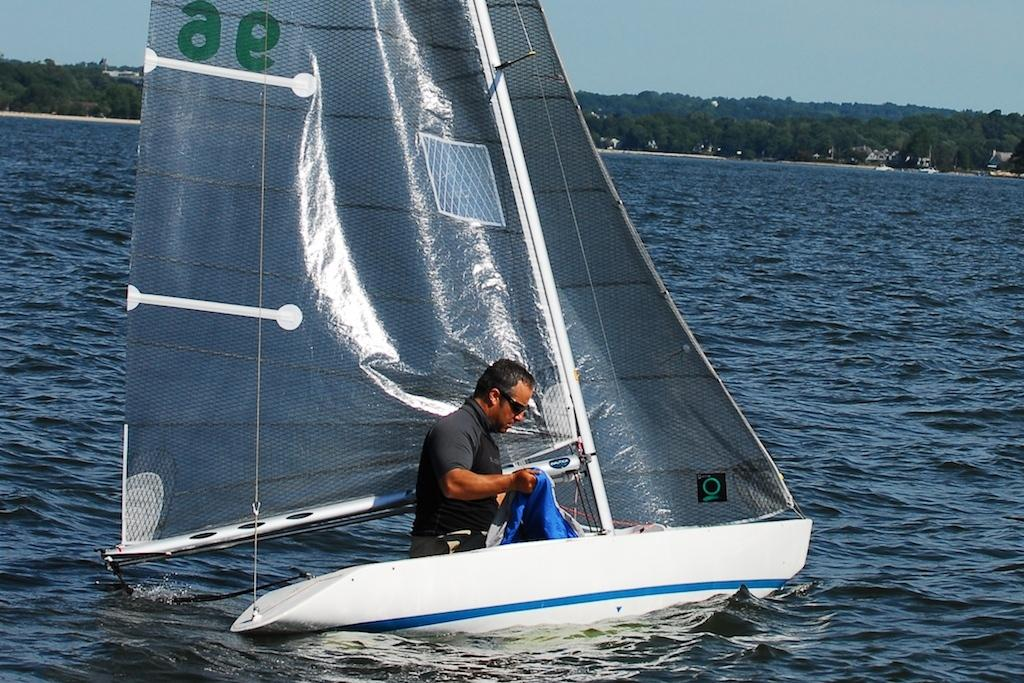What is the man doing in the image? The man is in a boat in the image. Where is the boat located? The boat is on water in the image. What can be seen in the background of the image? There are trees in the background of the image. What is visible at the top of the image? The sky is visible at the top of the image. What type of design can be seen on the man's toe in the image? There is no information about the man's toe or any design on it in the image. 